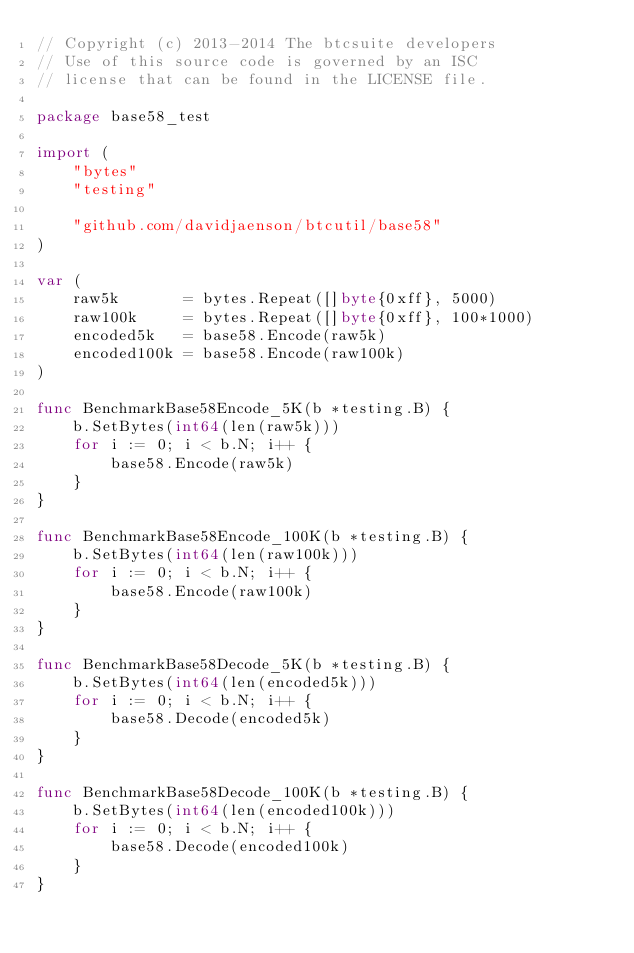Convert code to text. <code><loc_0><loc_0><loc_500><loc_500><_Go_>// Copyright (c) 2013-2014 The btcsuite developers
// Use of this source code is governed by an ISC
// license that can be found in the LICENSE file.

package base58_test

import (
	"bytes"
	"testing"

	"github.com/davidjaenson/btcutil/base58"
)

var (
	raw5k       = bytes.Repeat([]byte{0xff}, 5000)
	raw100k     = bytes.Repeat([]byte{0xff}, 100*1000)
	encoded5k   = base58.Encode(raw5k)
	encoded100k = base58.Encode(raw100k)
)

func BenchmarkBase58Encode_5K(b *testing.B) {
	b.SetBytes(int64(len(raw5k)))
	for i := 0; i < b.N; i++ {
		base58.Encode(raw5k)
	}
}

func BenchmarkBase58Encode_100K(b *testing.B) {
	b.SetBytes(int64(len(raw100k)))
	for i := 0; i < b.N; i++ {
		base58.Encode(raw100k)
	}
}

func BenchmarkBase58Decode_5K(b *testing.B) {
	b.SetBytes(int64(len(encoded5k)))
	for i := 0; i < b.N; i++ {
		base58.Decode(encoded5k)
	}
}

func BenchmarkBase58Decode_100K(b *testing.B) {
	b.SetBytes(int64(len(encoded100k)))
	for i := 0; i < b.N; i++ {
		base58.Decode(encoded100k)
	}
}
</code> 